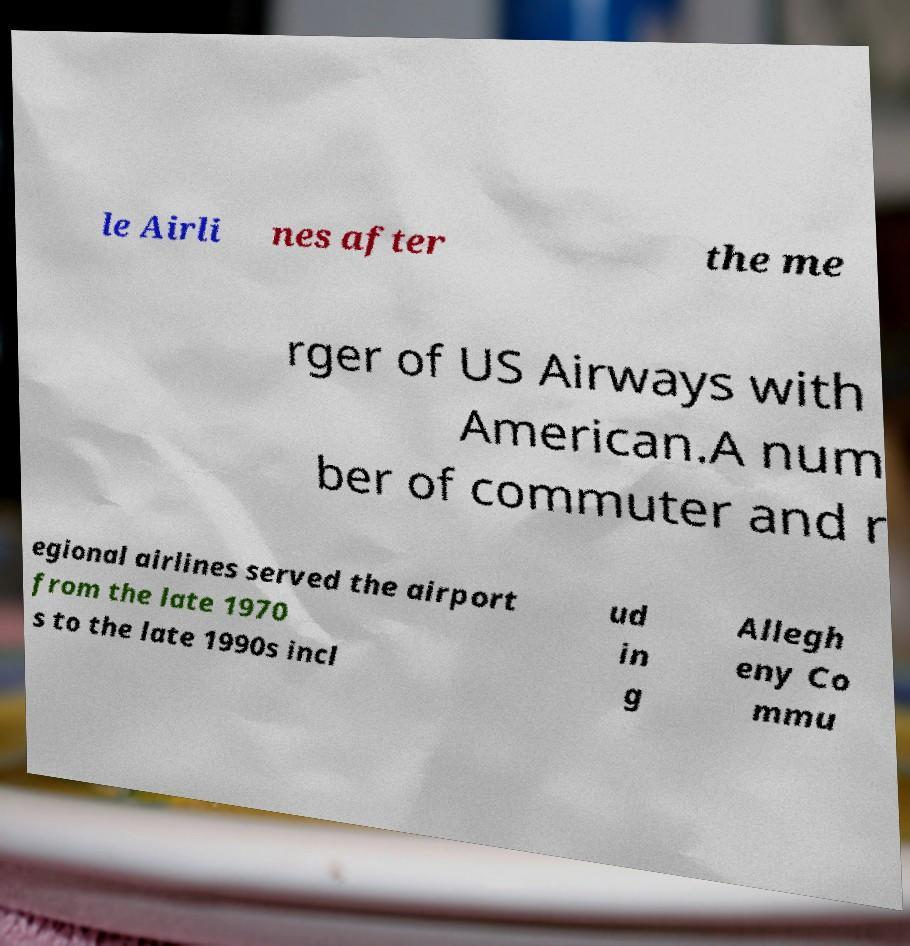Please identify and transcribe the text found in this image. le Airli nes after the me rger of US Airways with American.A num ber of commuter and r egional airlines served the airport from the late 1970 s to the late 1990s incl ud in g Allegh eny Co mmu 